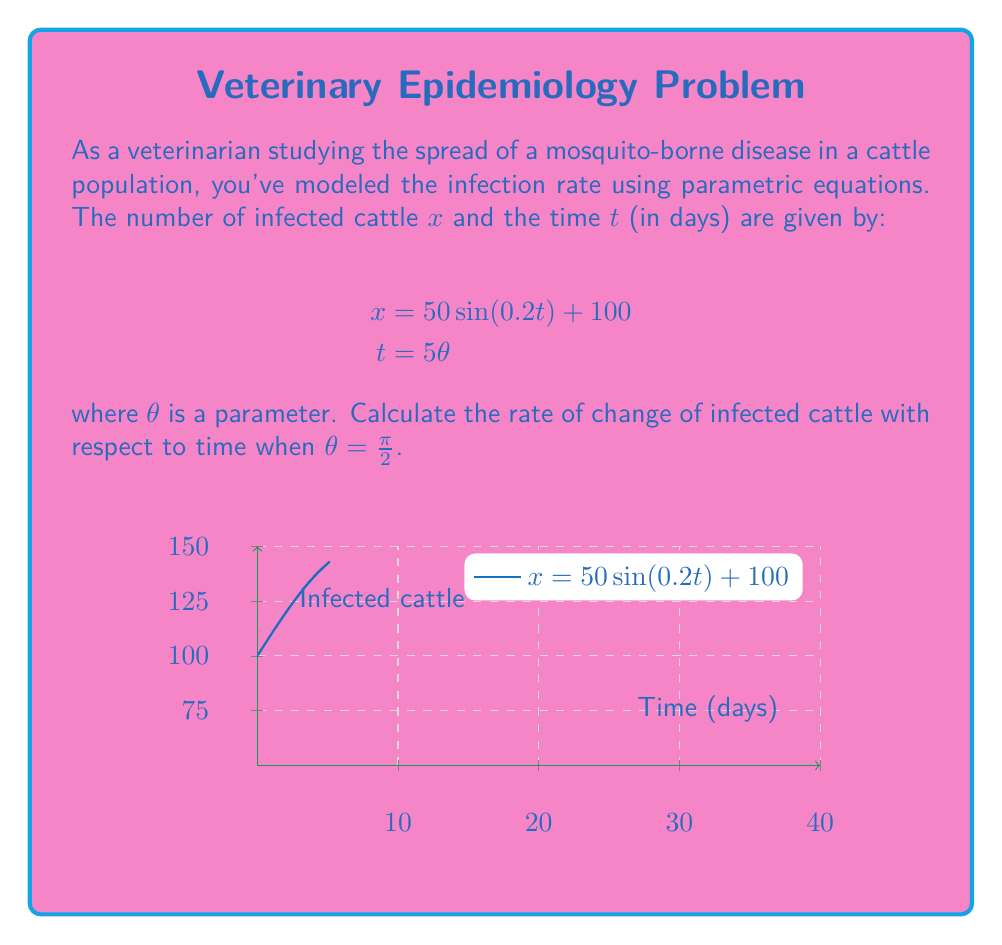Provide a solution to this math problem. To solve this problem, we'll follow these steps:

1) First, we need to find $\frac{dx}{d\theta}$ and $\frac{dt}{d\theta}$.

   From $x = 50\sin(0.2t) + 100$ and $t = 5\theta$, we get:
   
   $x = 50\sin(0.2(5\theta)) + 100 = 50\sin(\theta) + 100$

   So, $\frac{dx}{d\theta} = 50\cos(\theta)$

   And $\frac{dt}{d\theta} = 5$

2) The rate of change of infected cattle with respect to time is given by:

   $$\frac{dx}{dt} = \frac{dx/d\theta}{dt/d\theta} = \frac{50\cos(\theta)}{5} = 10\cos(\theta)$$

3) We need to evaluate this at $\theta = \pi/2$:

   $$\frac{dx}{dt}\bigg|_{\theta=\pi/2} = 10\cos(\pi/2) = 0$$

4) To interpret this result: When $\theta = \pi/2$, $t = 5(\pi/2) = 5\pi/2 \approx 7.85$ days. At this time, the rate of change of infected cattle is 0, indicating a turning point in the infection rate.
Answer: $0$ infected cattle per day 